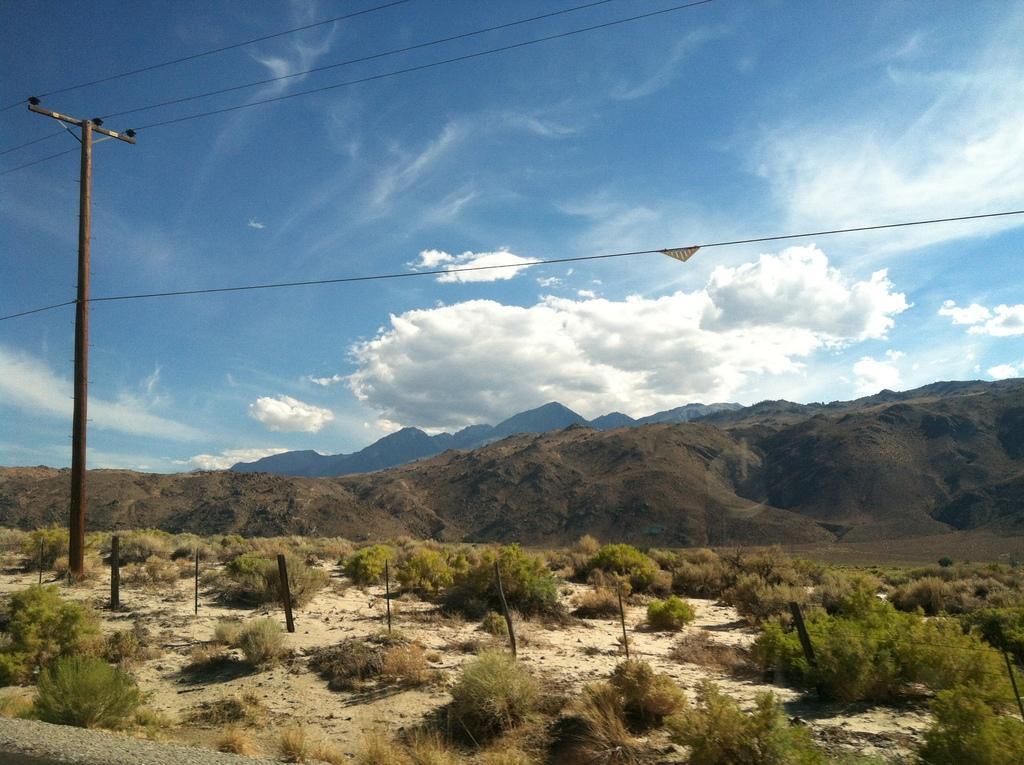Describe this image in one or two sentences. In this image we can see an electric pole with cables on top of it, on the surface, we can see some plants, in the background of the image there are mountains. 